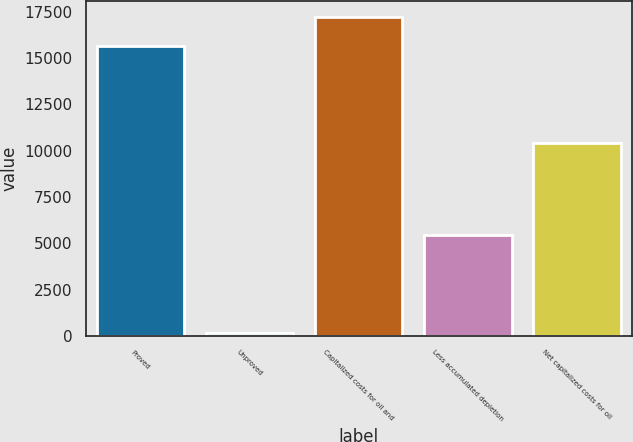<chart> <loc_0><loc_0><loc_500><loc_500><bar_chart><fcel>Proved<fcel>Unproved<fcel>Capitalized costs for oil and<fcel>Less accumulated depletion<fcel>Net capitalized costs for oil<nl><fcel>15662<fcel>159<fcel>17228.2<fcel>5431<fcel>10390<nl></chart> 